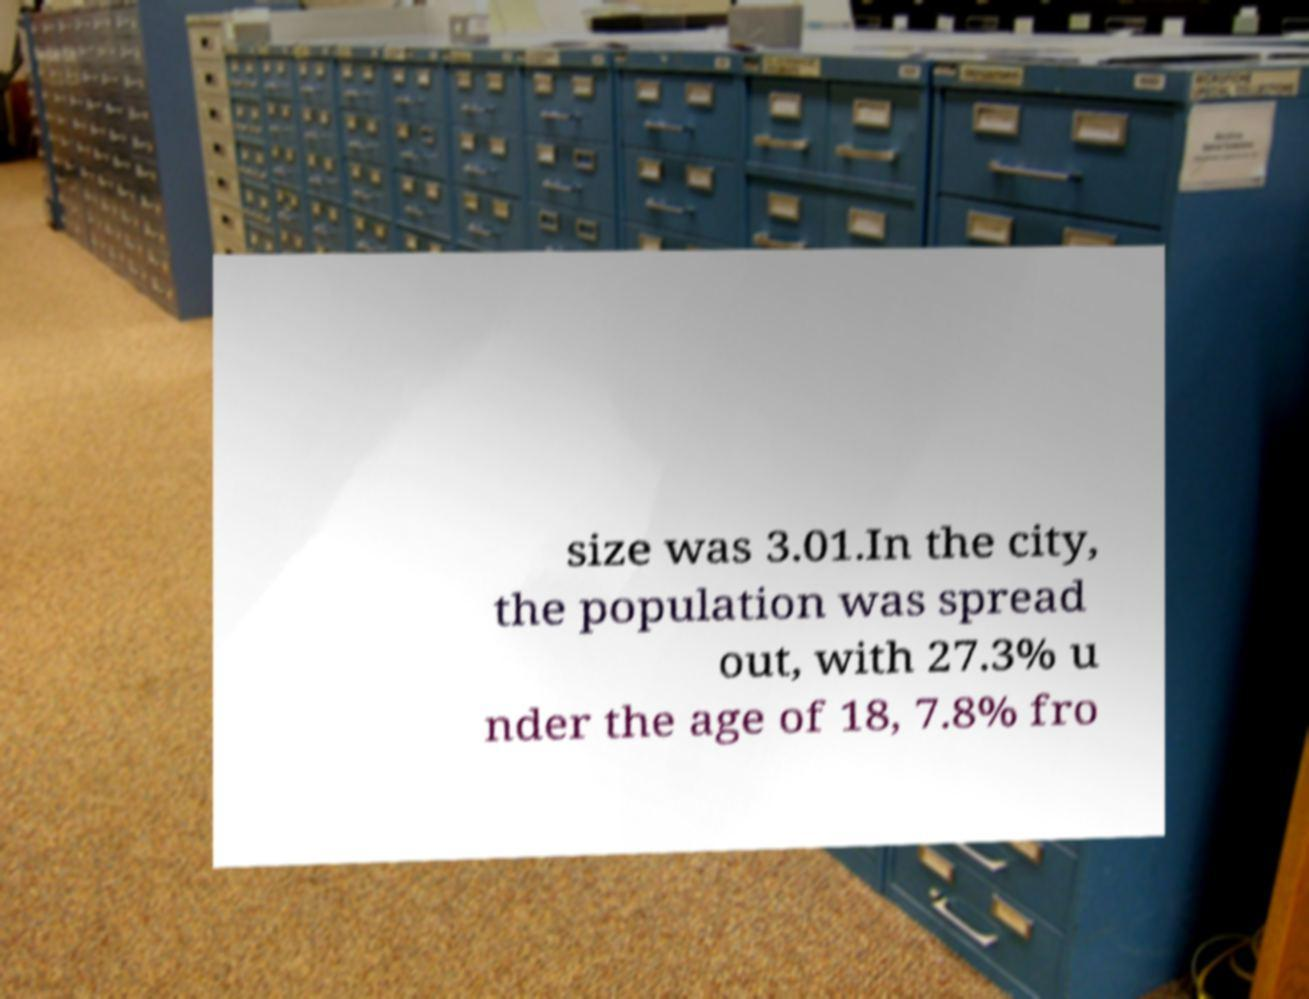Could you extract and type out the text from this image? size was 3.01.In the city, the population was spread out, with 27.3% u nder the age of 18, 7.8% fro 